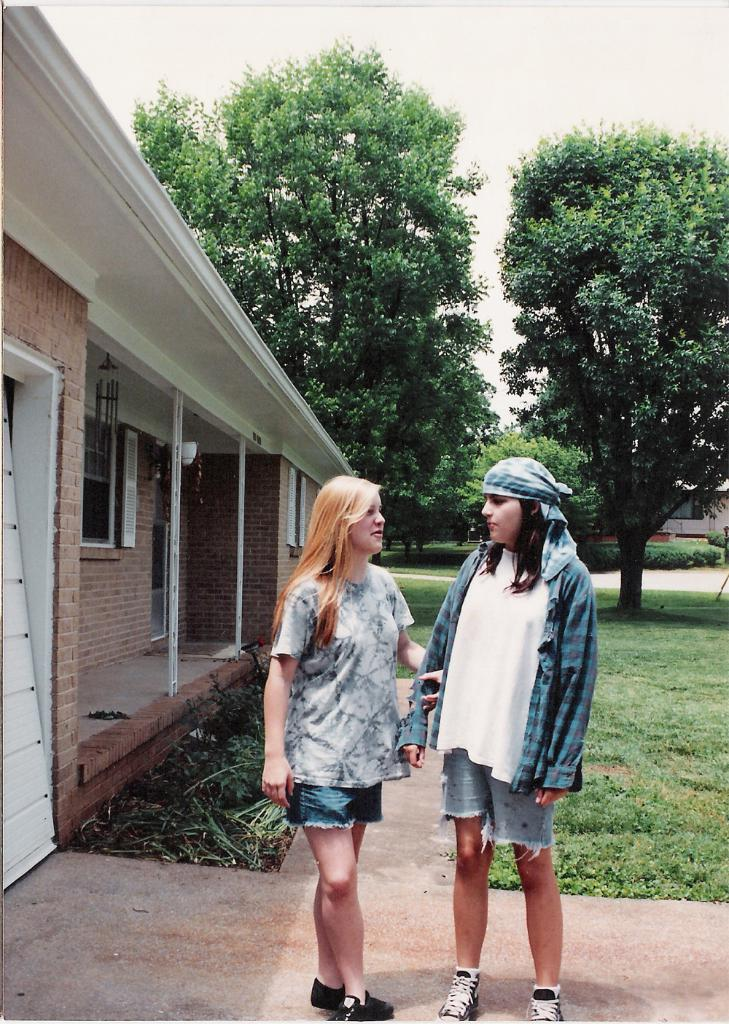How many people are visible in the image? There are two people standing in front of the image. What type of surface is at the bottom of the image? There is grass on the surface at the bottom of the image. What structures can be seen in the image? There are buildings in the image. What type of vegetation is present in the image? There are trees in the image. What is visible at the top of the image? The sky is visible at the top of the image. What type of key is being used to open the door in the image? There is no door or key present in the image. What direction are the people facing in the image? The provided facts do not mention the direction the people are facing, so it cannot be determined from the image. 